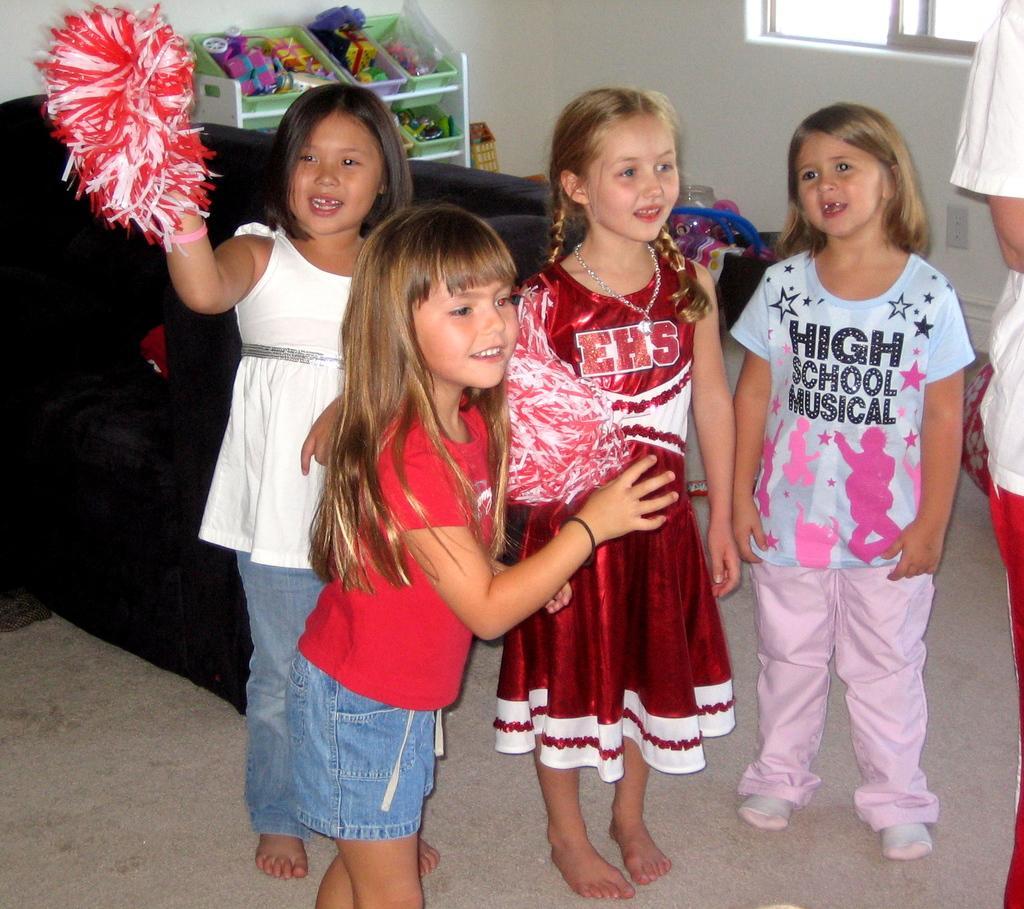Can you describe this image briefly? In this image we can see kids and a person standing on the floor, kids are holding few objects and in the background there is a couch, a stand with boxes and few objects in the box and there are few objects on the floor and a window to the wall. 